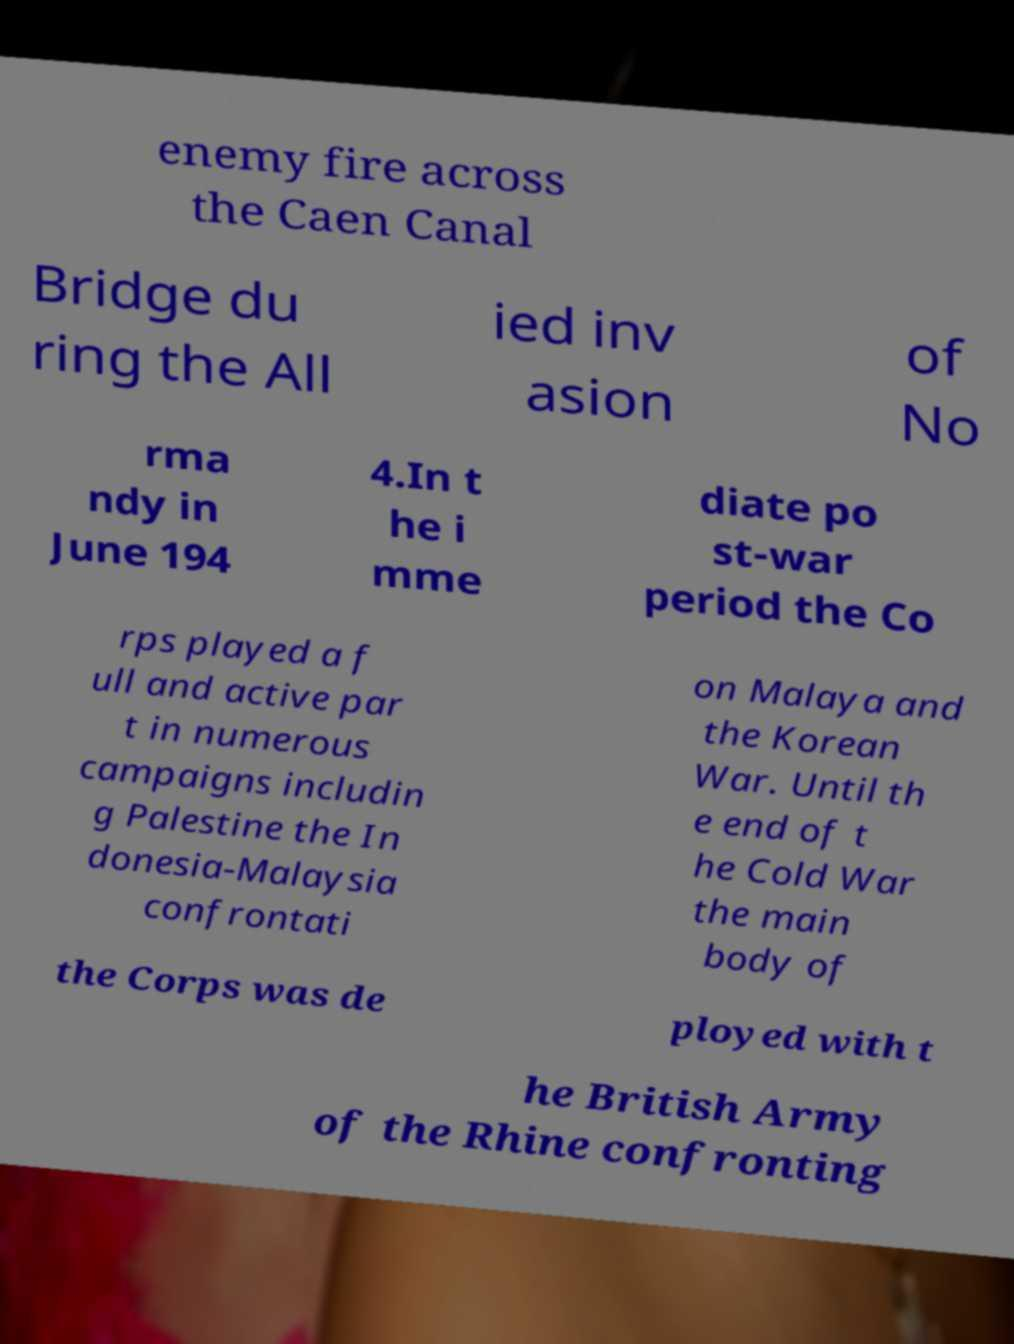Could you assist in decoding the text presented in this image and type it out clearly? enemy fire across the Caen Canal Bridge du ring the All ied inv asion of No rma ndy in June 194 4.In t he i mme diate po st-war period the Co rps played a f ull and active par t in numerous campaigns includin g Palestine the In donesia-Malaysia confrontati on Malaya and the Korean War. Until th e end of t he Cold War the main body of the Corps was de ployed with t he British Army of the Rhine confronting 